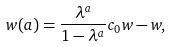Convert formula to latex. <formula><loc_0><loc_0><loc_500><loc_500>w ( a ) = \frac { \lambda ^ { a } } { 1 - \lambda ^ { a } } c _ { 0 } w - w ,</formula> 